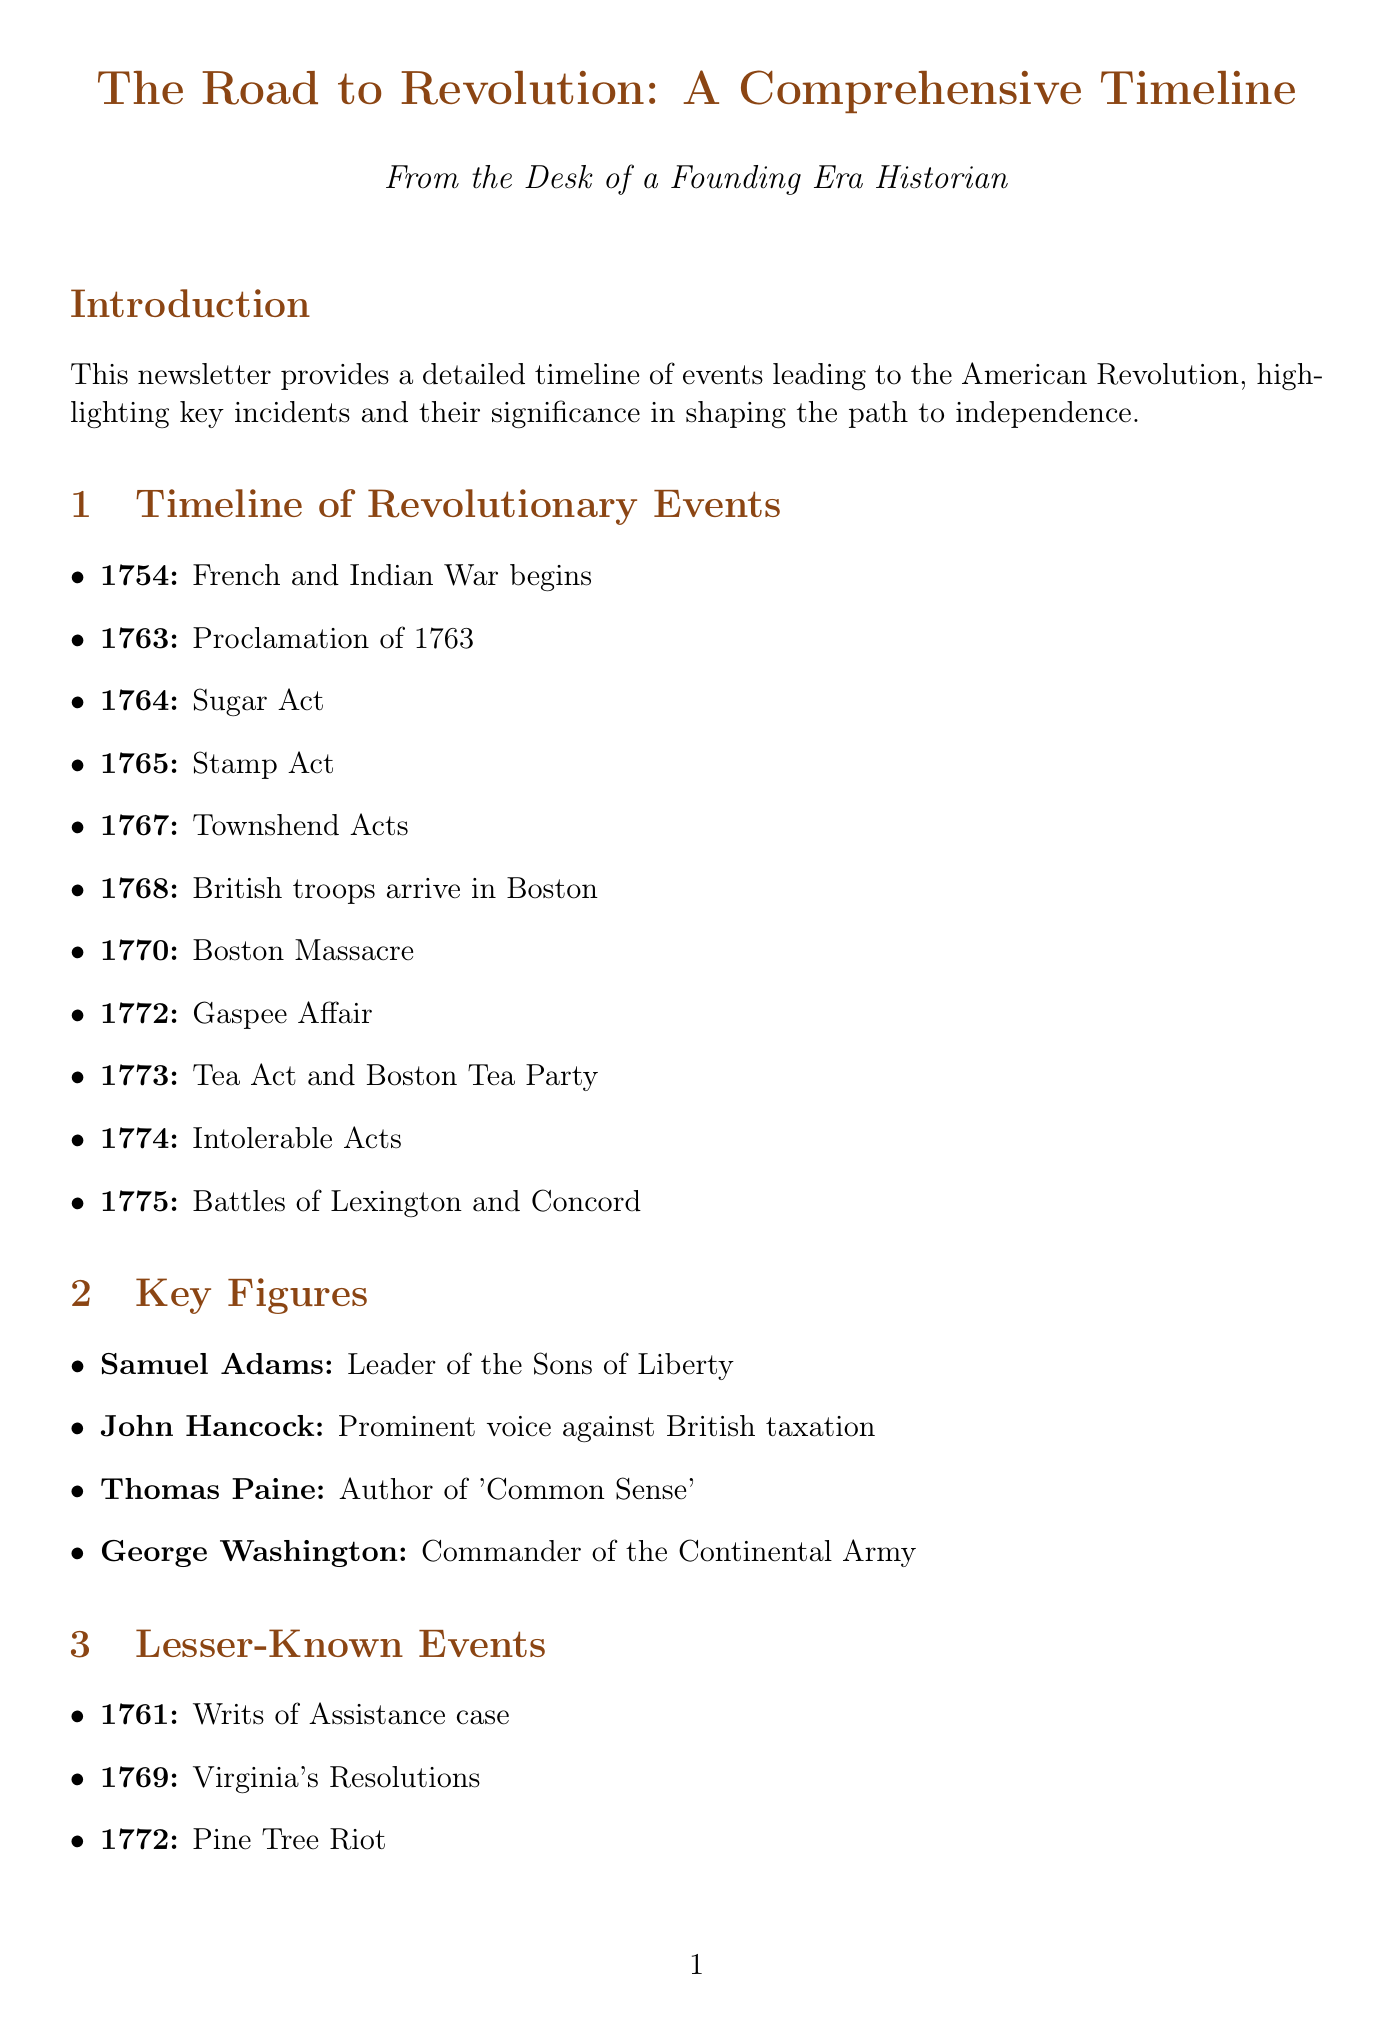What year did the French and Indian War begin? The document states that the French and Indian War began in 1754.
Answer: 1754 What event led to the Boston Massacre? The document indicates that the arrival of British troops in Boston escalated tensions, leading to the Boston Massacre.
Answer: British troops arrive in Boston Which act was the first direct tax on the colonies? According to the document, the Sugar Act is noted as the first direct tax on the colonies.
Answer: Sugar Act Who was the author of 'Common Sense'? The document lists Thomas Paine as the author of 'Common Sense'.
Answer: Thomas Paine What was the significance of the Intolerable Acts? The document explains that the Intolerable Acts united the colonies against perceived British tyranny.
Answer: United the colonies How did the Writs of Assistance case influence American rights? The document states that it was an early challenge to British authority and inspired the Fourth Amendment.
Answer: Inspired the Fourth Amendment What economic policy fueled colonial resentment? The document identifies Mercantilism as the British economic policy that fueled colonial resentment.
Answer: Mercantilism Which resolution demonstrated growing colonial unity? According to the document, Virginia's Resolutions asserted colonial rights and demonstrated unity.
Answer: Virginia's Resolutions What type of document is this? The document is structured as a newsletter focusing on the timeline of events leading to the American Revolution.
Answer: Newsletter 